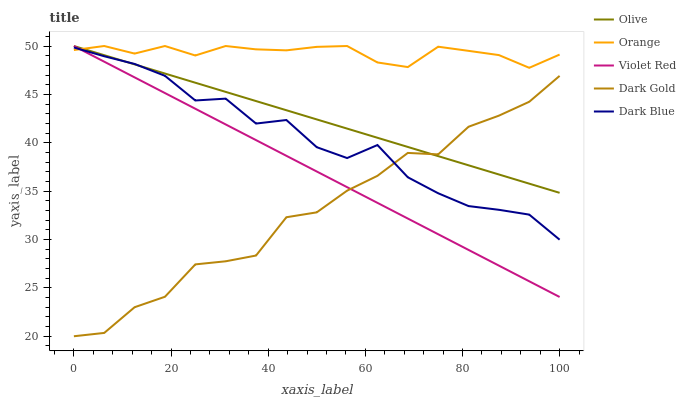Does Dark Gold have the minimum area under the curve?
Answer yes or no. Yes. Does Orange have the maximum area under the curve?
Answer yes or no. Yes. Does Violet Red have the minimum area under the curve?
Answer yes or no. No. Does Violet Red have the maximum area under the curve?
Answer yes or no. No. Is Violet Red the smoothest?
Answer yes or no. Yes. Is Dark Gold the roughest?
Answer yes or no. Yes. Is Orange the smoothest?
Answer yes or no. No. Is Orange the roughest?
Answer yes or no. No. Does Dark Gold have the lowest value?
Answer yes or no. Yes. Does Violet Red have the lowest value?
Answer yes or no. No. Does Violet Red have the highest value?
Answer yes or no. Yes. Does Dark Blue have the highest value?
Answer yes or no. No. Is Dark Gold less than Orange?
Answer yes or no. Yes. Is Orange greater than Dark Gold?
Answer yes or no. Yes. Does Dark Blue intersect Dark Gold?
Answer yes or no. Yes. Is Dark Blue less than Dark Gold?
Answer yes or no. No. Is Dark Blue greater than Dark Gold?
Answer yes or no. No. Does Dark Gold intersect Orange?
Answer yes or no. No. 